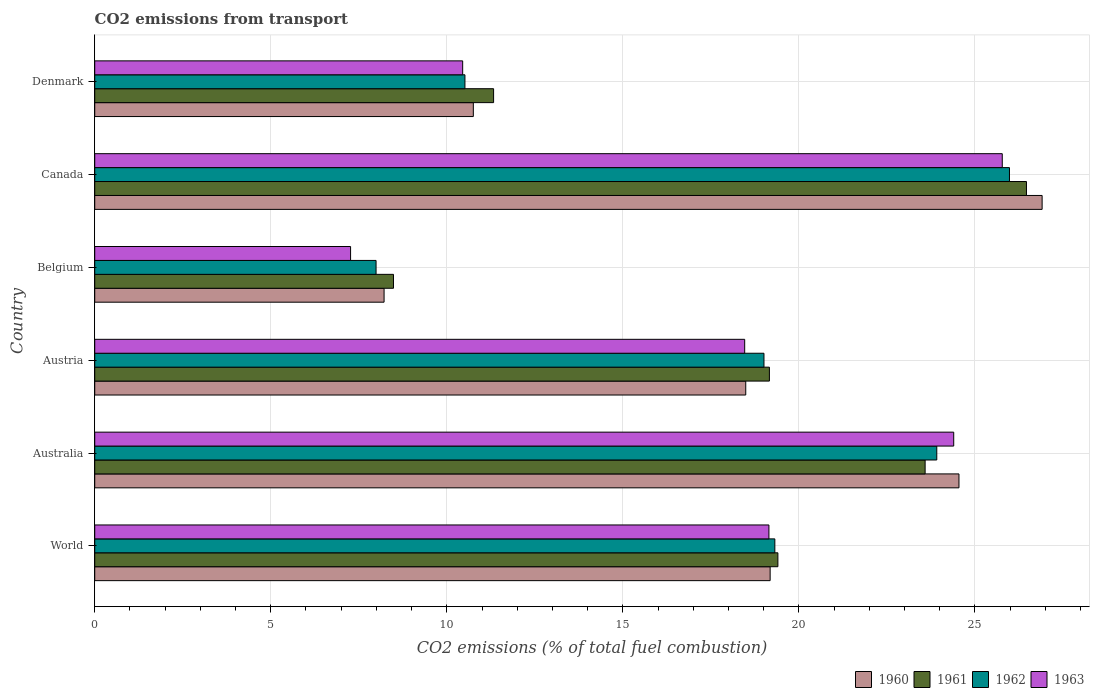How many different coloured bars are there?
Offer a very short reply. 4. How many groups of bars are there?
Make the answer very short. 6. How many bars are there on the 5th tick from the top?
Offer a terse response. 4. How many bars are there on the 3rd tick from the bottom?
Give a very brief answer. 4. In how many cases, is the number of bars for a given country not equal to the number of legend labels?
Give a very brief answer. 0. What is the total CO2 emitted in 1962 in Canada?
Give a very brief answer. 25.98. Across all countries, what is the maximum total CO2 emitted in 1960?
Your answer should be very brief. 26.91. Across all countries, what is the minimum total CO2 emitted in 1960?
Provide a short and direct response. 8.22. In which country was the total CO2 emitted in 1962 maximum?
Provide a short and direct response. Canada. In which country was the total CO2 emitted in 1961 minimum?
Offer a terse response. Belgium. What is the total total CO2 emitted in 1962 in the graph?
Offer a very short reply. 106.73. What is the difference between the total CO2 emitted in 1960 in Austria and that in World?
Your response must be concise. -0.69. What is the difference between the total CO2 emitted in 1963 in Austria and the total CO2 emitted in 1960 in World?
Offer a terse response. -0.72. What is the average total CO2 emitted in 1960 per country?
Provide a short and direct response. 18.02. What is the difference between the total CO2 emitted in 1963 and total CO2 emitted in 1961 in Denmark?
Make the answer very short. -0.88. What is the ratio of the total CO2 emitted in 1960 in Canada to that in Denmark?
Your response must be concise. 2.5. What is the difference between the highest and the second highest total CO2 emitted in 1962?
Your answer should be very brief. 2.06. What is the difference between the highest and the lowest total CO2 emitted in 1960?
Provide a succinct answer. 18.69. In how many countries, is the total CO2 emitted in 1960 greater than the average total CO2 emitted in 1960 taken over all countries?
Offer a very short reply. 4. What does the 2nd bar from the top in Belgium represents?
Make the answer very short. 1962. What is the difference between two consecutive major ticks on the X-axis?
Provide a succinct answer. 5. Are the values on the major ticks of X-axis written in scientific E-notation?
Make the answer very short. No. Does the graph contain any zero values?
Provide a short and direct response. No. Where does the legend appear in the graph?
Provide a succinct answer. Bottom right. How are the legend labels stacked?
Keep it short and to the point. Horizontal. What is the title of the graph?
Your answer should be compact. CO2 emissions from transport. Does "2011" appear as one of the legend labels in the graph?
Make the answer very short. No. What is the label or title of the X-axis?
Give a very brief answer. CO2 emissions (% of total fuel combustion). What is the label or title of the Y-axis?
Your response must be concise. Country. What is the CO2 emissions (% of total fuel combustion) in 1960 in World?
Offer a very short reply. 19.18. What is the CO2 emissions (% of total fuel combustion) in 1961 in World?
Provide a short and direct response. 19.4. What is the CO2 emissions (% of total fuel combustion) of 1962 in World?
Offer a terse response. 19.32. What is the CO2 emissions (% of total fuel combustion) in 1963 in World?
Your response must be concise. 19.15. What is the CO2 emissions (% of total fuel combustion) in 1960 in Australia?
Offer a very short reply. 24.55. What is the CO2 emissions (% of total fuel combustion) in 1961 in Australia?
Give a very brief answer. 23.59. What is the CO2 emissions (% of total fuel combustion) in 1962 in Australia?
Provide a succinct answer. 23.92. What is the CO2 emissions (% of total fuel combustion) in 1963 in Australia?
Ensure brevity in your answer.  24.4. What is the CO2 emissions (% of total fuel combustion) of 1960 in Austria?
Offer a very short reply. 18.49. What is the CO2 emissions (% of total fuel combustion) of 1961 in Austria?
Offer a terse response. 19.16. What is the CO2 emissions (% of total fuel combustion) of 1962 in Austria?
Provide a short and direct response. 19.01. What is the CO2 emissions (% of total fuel combustion) in 1963 in Austria?
Offer a very short reply. 18.46. What is the CO2 emissions (% of total fuel combustion) in 1960 in Belgium?
Offer a terse response. 8.22. What is the CO2 emissions (% of total fuel combustion) in 1961 in Belgium?
Ensure brevity in your answer.  8.49. What is the CO2 emissions (% of total fuel combustion) of 1962 in Belgium?
Offer a very short reply. 7.99. What is the CO2 emissions (% of total fuel combustion) of 1963 in Belgium?
Offer a terse response. 7.27. What is the CO2 emissions (% of total fuel combustion) in 1960 in Canada?
Give a very brief answer. 26.91. What is the CO2 emissions (% of total fuel combustion) in 1961 in Canada?
Offer a terse response. 26.46. What is the CO2 emissions (% of total fuel combustion) in 1962 in Canada?
Keep it short and to the point. 25.98. What is the CO2 emissions (% of total fuel combustion) of 1963 in Canada?
Provide a succinct answer. 25.78. What is the CO2 emissions (% of total fuel combustion) of 1960 in Denmark?
Your answer should be very brief. 10.75. What is the CO2 emissions (% of total fuel combustion) of 1961 in Denmark?
Offer a terse response. 11.33. What is the CO2 emissions (% of total fuel combustion) of 1962 in Denmark?
Offer a very short reply. 10.51. What is the CO2 emissions (% of total fuel combustion) of 1963 in Denmark?
Keep it short and to the point. 10.45. Across all countries, what is the maximum CO2 emissions (% of total fuel combustion) of 1960?
Make the answer very short. 26.91. Across all countries, what is the maximum CO2 emissions (% of total fuel combustion) of 1961?
Offer a terse response. 26.46. Across all countries, what is the maximum CO2 emissions (% of total fuel combustion) in 1962?
Offer a terse response. 25.98. Across all countries, what is the maximum CO2 emissions (% of total fuel combustion) of 1963?
Your response must be concise. 25.78. Across all countries, what is the minimum CO2 emissions (% of total fuel combustion) of 1960?
Ensure brevity in your answer.  8.22. Across all countries, what is the minimum CO2 emissions (% of total fuel combustion) of 1961?
Make the answer very short. 8.49. Across all countries, what is the minimum CO2 emissions (% of total fuel combustion) of 1962?
Keep it short and to the point. 7.99. Across all countries, what is the minimum CO2 emissions (% of total fuel combustion) of 1963?
Offer a very short reply. 7.27. What is the total CO2 emissions (% of total fuel combustion) of 1960 in the graph?
Your answer should be very brief. 108.1. What is the total CO2 emissions (% of total fuel combustion) of 1961 in the graph?
Offer a terse response. 108.43. What is the total CO2 emissions (% of total fuel combustion) of 1962 in the graph?
Ensure brevity in your answer.  106.73. What is the total CO2 emissions (% of total fuel combustion) of 1963 in the graph?
Your answer should be compact. 105.5. What is the difference between the CO2 emissions (% of total fuel combustion) of 1960 in World and that in Australia?
Your answer should be very brief. -5.36. What is the difference between the CO2 emissions (% of total fuel combustion) of 1961 in World and that in Australia?
Provide a short and direct response. -4.18. What is the difference between the CO2 emissions (% of total fuel combustion) of 1962 in World and that in Australia?
Make the answer very short. -4.6. What is the difference between the CO2 emissions (% of total fuel combustion) of 1963 in World and that in Australia?
Offer a very short reply. -5.25. What is the difference between the CO2 emissions (% of total fuel combustion) of 1960 in World and that in Austria?
Keep it short and to the point. 0.69. What is the difference between the CO2 emissions (% of total fuel combustion) of 1961 in World and that in Austria?
Provide a succinct answer. 0.24. What is the difference between the CO2 emissions (% of total fuel combustion) of 1962 in World and that in Austria?
Your answer should be compact. 0.31. What is the difference between the CO2 emissions (% of total fuel combustion) of 1963 in World and that in Austria?
Ensure brevity in your answer.  0.69. What is the difference between the CO2 emissions (% of total fuel combustion) of 1960 in World and that in Belgium?
Your answer should be compact. 10.96. What is the difference between the CO2 emissions (% of total fuel combustion) of 1961 in World and that in Belgium?
Offer a terse response. 10.92. What is the difference between the CO2 emissions (% of total fuel combustion) of 1962 in World and that in Belgium?
Your answer should be very brief. 11.33. What is the difference between the CO2 emissions (% of total fuel combustion) in 1963 in World and that in Belgium?
Offer a terse response. 11.88. What is the difference between the CO2 emissions (% of total fuel combustion) of 1960 in World and that in Canada?
Your response must be concise. -7.72. What is the difference between the CO2 emissions (% of total fuel combustion) in 1961 in World and that in Canada?
Provide a short and direct response. -7.06. What is the difference between the CO2 emissions (% of total fuel combustion) in 1962 in World and that in Canada?
Offer a very short reply. -6.66. What is the difference between the CO2 emissions (% of total fuel combustion) in 1963 in World and that in Canada?
Your answer should be compact. -6.63. What is the difference between the CO2 emissions (% of total fuel combustion) in 1960 in World and that in Denmark?
Your response must be concise. 8.43. What is the difference between the CO2 emissions (% of total fuel combustion) in 1961 in World and that in Denmark?
Ensure brevity in your answer.  8.07. What is the difference between the CO2 emissions (% of total fuel combustion) in 1962 in World and that in Denmark?
Your response must be concise. 8.8. What is the difference between the CO2 emissions (% of total fuel combustion) of 1963 in World and that in Denmark?
Offer a terse response. 8.7. What is the difference between the CO2 emissions (% of total fuel combustion) in 1960 in Australia and that in Austria?
Provide a short and direct response. 6.06. What is the difference between the CO2 emissions (% of total fuel combustion) of 1961 in Australia and that in Austria?
Offer a very short reply. 4.42. What is the difference between the CO2 emissions (% of total fuel combustion) of 1962 in Australia and that in Austria?
Your answer should be very brief. 4.91. What is the difference between the CO2 emissions (% of total fuel combustion) in 1963 in Australia and that in Austria?
Ensure brevity in your answer.  5.94. What is the difference between the CO2 emissions (% of total fuel combustion) of 1960 in Australia and that in Belgium?
Your answer should be very brief. 16.33. What is the difference between the CO2 emissions (% of total fuel combustion) in 1961 in Australia and that in Belgium?
Your response must be concise. 15.1. What is the difference between the CO2 emissions (% of total fuel combustion) in 1962 in Australia and that in Belgium?
Ensure brevity in your answer.  15.93. What is the difference between the CO2 emissions (% of total fuel combustion) in 1963 in Australia and that in Belgium?
Ensure brevity in your answer.  17.13. What is the difference between the CO2 emissions (% of total fuel combustion) of 1960 in Australia and that in Canada?
Provide a succinct answer. -2.36. What is the difference between the CO2 emissions (% of total fuel combustion) in 1961 in Australia and that in Canada?
Your answer should be compact. -2.88. What is the difference between the CO2 emissions (% of total fuel combustion) of 1962 in Australia and that in Canada?
Provide a succinct answer. -2.06. What is the difference between the CO2 emissions (% of total fuel combustion) of 1963 in Australia and that in Canada?
Make the answer very short. -1.38. What is the difference between the CO2 emissions (% of total fuel combustion) in 1960 in Australia and that in Denmark?
Provide a succinct answer. 13.79. What is the difference between the CO2 emissions (% of total fuel combustion) of 1961 in Australia and that in Denmark?
Your response must be concise. 12.26. What is the difference between the CO2 emissions (% of total fuel combustion) of 1962 in Australia and that in Denmark?
Your answer should be very brief. 13.4. What is the difference between the CO2 emissions (% of total fuel combustion) in 1963 in Australia and that in Denmark?
Provide a succinct answer. 13.95. What is the difference between the CO2 emissions (% of total fuel combustion) in 1960 in Austria and that in Belgium?
Provide a short and direct response. 10.27. What is the difference between the CO2 emissions (% of total fuel combustion) of 1961 in Austria and that in Belgium?
Keep it short and to the point. 10.68. What is the difference between the CO2 emissions (% of total fuel combustion) in 1962 in Austria and that in Belgium?
Your answer should be compact. 11.02. What is the difference between the CO2 emissions (% of total fuel combustion) of 1963 in Austria and that in Belgium?
Provide a short and direct response. 11.19. What is the difference between the CO2 emissions (% of total fuel combustion) of 1960 in Austria and that in Canada?
Your answer should be compact. -8.42. What is the difference between the CO2 emissions (% of total fuel combustion) in 1961 in Austria and that in Canada?
Ensure brevity in your answer.  -7.3. What is the difference between the CO2 emissions (% of total fuel combustion) of 1962 in Austria and that in Canada?
Make the answer very short. -6.97. What is the difference between the CO2 emissions (% of total fuel combustion) of 1963 in Austria and that in Canada?
Keep it short and to the point. -7.32. What is the difference between the CO2 emissions (% of total fuel combustion) in 1960 in Austria and that in Denmark?
Give a very brief answer. 7.74. What is the difference between the CO2 emissions (% of total fuel combustion) of 1961 in Austria and that in Denmark?
Ensure brevity in your answer.  7.83. What is the difference between the CO2 emissions (% of total fuel combustion) of 1962 in Austria and that in Denmark?
Offer a very short reply. 8.49. What is the difference between the CO2 emissions (% of total fuel combustion) of 1963 in Austria and that in Denmark?
Your response must be concise. 8.01. What is the difference between the CO2 emissions (% of total fuel combustion) of 1960 in Belgium and that in Canada?
Ensure brevity in your answer.  -18.69. What is the difference between the CO2 emissions (% of total fuel combustion) in 1961 in Belgium and that in Canada?
Keep it short and to the point. -17.98. What is the difference between the CO2 emissions (% of total fuel combustion) of 1962 in Belgium and that in Canada?
Provide a succinct answer. -17.99. What is the difference between the CO2 emissions (% of total fuel combustion) in 1963 in Belgium and that in Canada?
Your response must be concise. -18.51. What is the difference between the CO2 emissions (% of total fuel combustion) in 1960 in Belgium and that in Denmark?
Give a very brief answer. -2.53. What is the difference between the CO2 emissions (% of total fuel combustion) in 1961 in Belgium and that in Denmark?
Offer a very short reply. -2.84. What is the difference between the CO2 emissions (% of total fuel combustion) of 1962 in Belgium and that in Denmark?
Your answer should be very brief. -2.52. What is the difference between the CO2 emissions (% of total fuel combustion) in 1963 in Belgium and that in Denmark?
Offer a terse response. -3.18. What is the difference between the CO2 emissions (% of total fuel combustion) in 1960 in Canada and that in Denmark?
Give a very brief answer. 16.16. What is the difference between the CO2 emissions (% of total fuel combustion) in 1961 in Canada and that in Denmark?
Give a very brief answer. 15.13. What is the difference between the CO2 emissions (% of total fuel combustion) of 1962 in Canada and that in Denmark?
Provide a short and direct response. 15.47. What is the difference between the CO2 emissions (% of total fuel combustion) of 1963 in Canada and that in Denmark?
Offer a terse response. 15.33. What is the difference between the CO2 emissions (% of total fuel combustion) in 1960 in World and the CO2 emissions (% of total fuel combustion) in 1961 in Australia?
Give a very brief answer. -4.4. What is the difference between the CO2 emissions (% of total fuel combustion) of 1960 in World and the CO2 emissions (% of total fuel combustion) of 1962 in Australia?
Provide a succinct answer. -4.73. What is the difference between the CO2 emissions (% of total fuel combustion) of 1960 in World and the CO2 emissions (% of total fuel combustion) of 1963 in Australia?
Provide a short and direct response. -5.21. What is the difference between the CO2 emissions (% of total fuel combustion) of 1961 in World and the CO2 emissions (% of total fuel combustion) of 1962 in Australia?
Provide a succinct answer. -4.51. What is the difference between the CO2 emissions (% of total fuel combustion) in 1961 in World and the CO2 emissions (% of total fuel combustion) in 1963 in Australia?
Make the answer very short. -4.99. What is the difference between the CO2 emissions (% of total fuel combustion) in 1962 in World and the CO2 emissions (% of total fuel combustion) in 1963 in Australia?
Make the answer very short. -5.08. What is the difference between the CO2 emissions (% of total fuel combustion) in 1960 in World and the CO2 emissions (% of total fuel combustion) in 1961 in Austria?
Make the answer very short. 0.02. What is the difference between the CO2 emissions (% of total fuel combustion) of 1960 in World and the CO2 emissions (% of total fuel combustion) of 1962 in Austria?
Your answer should be very brief. 0.18. What is the difference between the CO2 emissions (% of total fuel combustion) in 1960 in World and the CO2 emissions (% of total fuel combustion) in 1963 in Austria?
Provide a short and direct response. 0.72. What is the difference between the CO2 emissions (% of total fuel combustion) in 1961 in World and the CO2 emissions (% of total fuel combustion) in 1962 in Austria?
Your answer should be very brief. 0.4. What is the difference between the CO2 emissions (% of total fuel combustion) of 1961 in World and the CO2 emissions (% of total fuel combustion) of 1963 in Austria?
Offer a terse response. 0.94. What is the difference between the CO2 emissions (% of total fuel combustion) of 1962 in World and the CO2 emissions (% of total fuel combustion) of 1963 in Austria?
Ensure brevity in your answer.  0.86. What is the difference between the CO2 emissions (% of total fuel combustion) of 1960 in World and the CO2 emissions (% of total fuel combustion) of 1961 in Belgium?
Offer a terse response. 10.7. What is the difference between the CO2 emissions (% of total fuel combustion) of 1960 in World and the CO2 emissions (% of total fuel combustion) of 1962 in Belgium?
Make the answer very short. 11.19. What is the difference between the CO2 emissions (% of total fuel combustion) of 1960 in World and the CO2 emissions (% of total fuel combustion) of 1963 in Belgium?
Ensure brevity in your answer.  11.92. What is the difference between the CO2 emissions (% of total fuel combustion) of 1961 in World and the CO2 emissions (% of total fuel combustion) of 1962 in Belgium?
Ensure brevity in your answer.  11.41. What is the difference between the CO2 emissions (% of total fuel combustion) in 1961 in World and the CO2 emissions (% of total fuel combustion) in 1963 in Belgium?
Your answer should be compact. 12.14. What is the difference between the CO2 emissions (% of total fuel combustion) of 1962 in World and the CO2 emissions (% of total fuel combustion) of 1963 in Belgium?
Make the answer very short. 12.05. What is the difference between the CO2 emissions (% of total fuel combustion) of 1960 in World and the CO2 emissions (% of total fuel combustion) of 1961 in Canada?
Your response must be concise. -7.28. What is the difference between the CO2 emissions (% of total fuel combustion) in 1960 in World and the CO2 emissions (% of total fuel combustion) in 1962 in Canada?
Keep it short and to the point. -6.8. What is the difference between the CO2 emissions (% of total fuel combustion) in 1960 in World and the CO2 emissions (% of total fuel combustion) in 1963 in Canada?
Provide a short and direct response. -6.59. What is the difference between the CO2 emissions (% of total fuel combustion) of 1961 in World and the CO2 emissions (% of total fuel combustion) of 1962 in Canada?
Offer a terse response. -6.58. What is the difference between the CO2 emissions (% of total fuel combustion) in 1961 in World and the CO2 emissions (% of total fuel combustion) in 1963 in Canada?
Provide a succinct answer. -6.37. What is the difference between the CO2 emissions (% of total fuel combustion) in 1962 in World and the CO2 emissions (% of total fuel combustion) in 1963 in Canada?
Ensure brevity in your answer.  -6.46. What is the difference between the CO2 emissions (% of total fuel combustion) of 1960 in World and the CO2 emissions (% of total fuel combustion) of 1961 in Denmark?
Your response must be concise. 7.85. What is the difference between the CO2 emissions (% of total fuel combustion) of 1960 in World and the CO2 emissions (% of total fuel combustion) of 1962 in Denmark?
Offer a terse response. 8.67. What is the difference between the CO2 emissions (% of total fuel combustion) in 1960 in World and the CO2 emissions (% of total fuel combustion) in 1963 in Denmark?
Your answer should be compact. 8.73. What is the difference between the CO2 emissions (% of total fuel combustion) in 1961 in World and the CO2 emissions (% of total fuel combustion) in 1962 in Denmark?
Your answer should be compact. 8.89. What is the difference between the CO2 emissions (% of total fuel combustion) of 1961 in World and the CO2 emissions (% of total fuel combustion) of 1963 in Denmark?
Your answer should be compact. 8.95. What is the difference between the CO2 emissions (% of total fuel combustion) of 1962 in World and the CO2 emissions (% of total fuel combustion) of 1963 in Denmark?
Your answer should be very brief. 8.87. What is the difference between the CO2 emissions (% of total fuel combustion) in 1960 in Australia and the CO2 emissions (% of total fuel combustion) in 1961 in Austria?
Make the answer very short. 5.38. What is the difference between the CO2 emissions (% of total fuel combustion) of 1960 in Australia and the CO2 emissions (% of total fuel combustion) of 1962 in Austria?
Provide a succinct answer. 5.54. What is the difference between the CO2 emissions (% of total fuel combustion) of 1960 in Australia and the CO2 emissions (% of total fuel combustion) of 1963 in Austria?
Your answer should be compact. 6.09. What is the difference between the CO2 emissions (% of total fuel combustion) of 1961 in Australia and the CO2 emissions (% of total fuel combustion) of 1962 in Austria?
Give a very brief answer. 4.58. What is the difference between the CO2 emissions (% of total fuel combustion) in 1961 in Australia and the CO2 emissions (% of total fuel combustion) in 1963 in Austria?
Your answer should be very brief. 5.13. What is the difference between the CO2 emissions (% of total fuel combustion) in 1962 in Australia and the CO2 emissions (% of total fuel combustion) in 1963 in Austria?
Ensure brevity in your answer.  5.46. What is the difference between the CO2 emissions (% of total fuel combustion) of 1960 in Australia and the CO2 emissions (% of total fuel combustion) of 1961 in Belgium?
Make the answer very short. 16.06. What is the difference between the CO2 emissions (% of total fuel combustion) in 1960 in Australia and the CO2 emissions (% of total fuel combustion) in 1962 in Belgium?
Provide a short and direct response. 16.56. What is the difference between the CO2 emissions (% of total fuel combustion) of 1960 in Australia and the CO2 emissions (% of total fuel combustion) of 1963 in Belgium?
Offer a terse response. 17.28. What is the difference between the CO2 emissions (% of total fuel combustion) of 1961 in Australia and the CO2 emissions (% of total fuel combustion) of 1962 in Belgium?
Your response must be concise. 15.59. What is the difference between the CO2 emissions (% of total fuel combustion) in 1961 in Australia and the CO2 emissions (% of total fuel combustion) in 1963 in Belgium?
Ensure brevity in your answer.  16.32. What is the difference between the CO2 emissions (% of total fuel combustion) in 1962 in Australia and the CO2 emissions (% of total fuel combustion) in 1963 in Belgium?
Give a very brief answer. 16.65. What is the difference between the CO2 emissions (% of total fuel combustion) in 1960 in Australia and the CO2 emissions (% of total fuel combustion) in 1961 in Canada?
Offer a terse response. -1.92. What is the difference between the CO2 emissions (% of total fuel combustion) in 1960 in Australia and the CO2 emissions (% of total fuel combustion) in 1962 in Canada?
Give a very brief answer. -1.43. What is the difference between the CO2 emissions (% of total fuel combustion) in 1960 in Australia and the CO2 emissions (% of total fuel combustion) in 1963 in Canada?
Make the answer very short. -1.23. What is the difference between the CO2 emissions (% of total fuel combustion) of 1961 in Australia and the CO2 emissions (% of total fuel combustion) of 1962 in Canada?
Ensure brevity in your answer.  -2.4. What is the difference between the CO2 emissions (% of total fuel combustion) of 1961 in Australia and the CO2 emissions (% of total fuel combustion) of 1963 in Canada?
Ensure brevity in your answer.  -2.19. What is the difference between the CO2 emissions (% of total fuel combustion) of 1962 in Australia and the CO2 emissions (% of total fuel combustion) of 1963 in Canada?
Make the answer very short. -1.86. What is the difference between the CO2 emissions (% of total fuel combustion) of 1960 in Australia and the CO2 emissions (% of total fuel combustion) of 1961 in Denmark?
Your answer should be compact. 13.22. What is the difference between the CO2 emissions (% of total fuel combustion) of 1960 in Australia and the CO2 emissions (% of total fuel combustion) of 1962 in Denmark?
Offer a terse response. 14.03. What is the difference between the CO2 emissions (% of total fuel combustion) of 1960 in Australia and the CO2 emissions (% of total fuel combustion) of 1963 in Denmark?
Your response must be concise. 14.1. What is the difference between the CO2 emissions (% of total fuel combustion) of 1961 in Australia and the CO2 emissions (% of total fuel combustion) of 1962 in Denmark?
Ensure brevity in your answer.  13.07. What is the difference between the CO2 emissions (% of total fuel combustion) in 1961 in Australia and the CO2 emissions (% of total fuel combustion) in 1963 in Denmark?
Provide a short and direct response. 13.13. What is the difference between the CO2 emissions (% of total fuel combustion) of 1962 in Australia and the CO2 emissions (% of total fuel combustion) of 1963 in Denmark?
Keep it short and to the point. 13.47. What is the difference between the CO2 emissions (% of total fuel combustion) of 1960 in Austria and the CO2 emissions (% of total fuel combustion) of 1961 in Belgium?
Your response must be concise. 10. What is the difference between the CO2 emissions (% of total fuel combustion) of 1960 in Austria and the CO2 emissions (% of total fuel combustion) of 1962 in Belgium?
Offer a very short reply. 10.5. What is the difference between the CO2 emissions (% of total fuel combustion) of 1960 in Austria and the CO2 emissions (% of total fuel combustion) of 1963 in Belgium?
Your response must be concise. 11.22. What is the difference between the CO2 emissions (% of total fuel combustion) of 1961 in Austria and the CO2 emissions (% of total fuel combustion) of 1962 in Belgium?
Provide a succinct answer. 11.17. What is the difference between the CO2 emissions (% of total fuel combustion) in 1961 in Austria and the CO2 emissions (% of total fuel combustion) in 1963 in Belgium?
Give a very brief answer. 11.9. What is the difference between the CO2 emissions (% of total fuel combustion) in 1962 in Austria and the CO2 emissions (% of total fuel combustion) in 1963 in Belgium?
Your answer should be compact. 11.74. What is the difference between the CO2 emissions (% of total fuel combustion) in 1960 in Austria and the CO2 emissions (% of total fuel combustion) in 1961 in Canada?
Keep it short and to the point. -7.97. What is the difference between the CO2 emissions (% of total fuel combustion) of 1960 in Austria and the CO2 emissions (% of total fuel combustion) of 1962 in Canada?
Your answer should be very brief. -7.49. What is the difference between the CO2 emissions (% of total fuel combustion) of 1960 in Austria and the CO2 emissions (% of total fuel combustion) of 1963 in Canada?
Keep it short and to the point. -7.29. What is the difference between the CO2 emissions (% of total fuel combustion) of 1961 in Austria and the CO2 emissions (% of total fuel combustion) of 1962 in Canada?
Keep it short and to the point. -6.82. What is the difference between the CO2 emissions (% of total fuel combustion) of 1961 in Austria and the CO2 emissions (% of total fuel combustion) of 1963 in Canada?
Your answer should be very brief. -6.61. What is the difference between the CO2 emissions (% of total fuel combustion) in 1962 in Austria and the CO2 emissions (% of total fuel combustion) in 1963 in Canada?
Provide a short and direct response. -6.77. What is the difference between the CO2 emissions (% of total fuel combustion) in 1960 in Austria and the CO2 emissions (% of total fuel combustion) in 1961 in Denmark?
Offer a very short reply. 7.16. What is the difference between the CO2 emissions (% of total fuel combustion) of 1960 in Austria and the CO2 emissions (% of total fuel combustion) of 1962 in Denmark?
Your answer should be very brief. 7.98. What is the difference between the CO2 emissions (% of total fuel combustion) in 1960 in Austria and the CO2 emissions (% of total fuel combustion) in 1963 in Denmark?
Ensure brevity in your answer.  8.04. What is the difference between the CO2 emissions (% of total fuel combustion) of 1961 in Austria and the CO2 emissions (% of total fuel combustion) of 1962 in Denmark?
Your answer should be very brief. 8.65. What is the difference between the CO2 emissions (% of total fuel combustion) of 1961 in Austria and the CO2 emissions (% of total fuel combustion) of 1963 in Denmark?
Make the answer very short. 8.71. What is the difference between the CO2 emissions (% of total fuel combustion) in 1962 in Austria and the CO2 emissions (% of total fuel combustion) in 1963 in Denmark?
Provide a succinct answer. 8.56. What is the difference between the CO2 emissions (% of total fuel combustion) in 1960 in Belgium and the CO2 emissions (% of total fuel combustion) in 1961 in Canada?
Offer a terse response. -18.25. What is the difference between the CO2 emissions (% of total fuel combustion) in 1960 in Belgium and the CO2 emissions (% of total fuel combustion) in 1962 in Canada?
Your response must be concise. -17.76. What is the difference between the CO2 emissions (% of total fuel combustion) of 1960 in Belgium and the CO2 emissions (% of total fuel combustion) of 1963 in Canada?
Your answer should be compact. -17.56. What is the difference between the CO2 emissions (% of total fuel combustion) in 1961 in Belgium and the CO2 emissions (% of total fuel combustion) in 1962 in Canada?
Your response must be concise. -17.5. What is the difference between the CO2 emissions (% of total fuel combustion) of 1961 in Belgium and the CO2 emissions (% of total fuel combustion) of 1963 in Canada?
Provide a short and direct response. -17.29. What is the difference between the CO2 emissions (% of total fuel combustion) of 1962 in Belgium and the CO2 emissions (% of total fuel combustion) of 1963 in Canada?
Offer a terse response. -17.79. What is the difference between the CO2 emissions (% of total fuel combustion) in 1960 in Belgium and the CO2 emissions (% of total fuel combustion) in 1961 in Denmark?
Ensure brevity in your answer.  -3.11. What is the difference between the CO2 emissions (% of total fuel combustion) in 1960 in Belgium and the CO2 emissions (% of total fuel combustion) in 1962 in Denmark?
Offer a terse response. -2.3. What is the difference between the CO2 emissions (% of total fuel combustion) in 1960 in Belgium and the CO2 emissions (% of total fuel combustion) in 1963 in Denmark?
Make the answer very short. -2.23. What is the difference between the CO2 emissions (% of total fuel combustion) in 1961 in Belgium and the CO2 emissions (% of total fuel combustion) in 1962 in Denmark?
Your answer should be compact. -2.03. What is the difference between the CO2 emissions (% of total fuel combustion) of 1961 in Belgium and the CO2 emissions (% of total fuel combustion) of 1963 in Denmark?
Keep it short and to the point. -1.96. What is the difference between the CO2 emissions (% of total fuel combustion) of 1962 in Belgium and the CO2 emissions (% of total fuel combustion) of 1963 in Denmark?
Your answer should be very brief. -2.46. What is the difference between the CO2 emissions (% of total fuel combustion) of 1960 in Canada and the CO2 emissions (% of total fuel combustion) of 1961 in Denmark?
Your answer should be very brief. 15.58. What is the difference between the CO2 emissions (% of total fuel combustion) of 1960 in Canada and the CO2 emissions (% of total fuel combustion) of 1962 in Denmark?
Give a very brief answer. 16.39. What is the difference between the CO2 emissions (% of total fuel combustion) of 1960 in Canada and the CO2 emissions (% of total fuel combustion) of 1963 in Denmark?
Keep it short and to the point. 16.46. What is the difference between the CO2 emissions (% of total fuel combustion) of 1961 in Canada and the CO2 emissions (% of total fuel combustion) of 1962 in Denmark?
Your response must be concise. 15.95. What is the difference between the CO2 emissions (% of total fuel combustion) in 1961 in Canada and the CO2 emissions (% of total fuel combustion) in 1963 in Denmark?
Keep it short and to the point. 16.01. What is the difference between the CO2 emissions (% of total fuel combustion) in 1962 in Canada and the CO2 emissions (% of total fuel combustion) in 1963 in Denmark?
Provide a short and direct response. 15.53. What is the average CO2 emissions (% of total fuel combustion) of 1960 per country?
Your answer should be very brief. 18.02. What is the average CO2 emissions (% of total fuel combustion) in 1961 per country?
Provide a succinct answer. 18.07. What is the average CO2 emissions (% of total fuel combustion) in 1962 per country?
Your answer should be compact. 17.79. What is the average CO2 emissions (% of total fuel combustion) in 1963 per country?
Your response must be concise. 17.58. What is the difference between the CO2 emissions (% of total fuel combustion) in 1960 and CO2 emissions (% of total fuel combustion) in 1961 in World?
Your answer should be compact. -0.22. What is the difference between the CO2 emissions (% of total fuel combustion) of 1960 and CO2 emissions (% of total fuel combustion) of 1962 in World?
Offer a terse response. -0.13. What is the difference between the CO2 emissions (% of total fuel combustion) in 1960 and CO2 emissions (% of total fuel combustion) in 1963 in World?
Give a very brief answer. 0.03. What is the difference between the CO2 emissions (% of total fuel combustion) of 1961 and CO2 emissions (% of total fuel combustion) of 1962 in World?
Make the answer very short. 0.09. What is the difference between the CO2 emissions (% of total fuel combustion) in 1961 and CO2 emissions (% of total fuel combustion) in 1963 in World?
Make the answer very short. 0.25. What is the difference between the CO2 emissions (% of total fuel combustion) of 1962 and CO2 emissions (% of total fuel combustion) of 1963 in World?
Make the answer very short. 0.17. What is the difference between the CO2 emissions (% of total fuel combustion) in 1960 and CO2 emissions (% of total fuel combustion) in 1961 in Australia?
Offer a terse response. 0.96. What is the difference between the CO2 emissions (% of total fuel combustion) of 1960 and CO2 emissions (% of total fuel combustion) of 1962 in Australia?
Your response must be concise. 0.63. What is the difference between the CO2 emissions (% of total fuel combustion) in 1960 and CO2 emissions (% of total fuel combustion) in 1963 in Australia?
Give a very brief answer. 0.15. What is the difference between the CO2 emissions (% of total fuel combustion) in 1961 and CO2 emissions (% of total fuel combustion) in 1962 in Australia?
Offer a very short reply. -0.33. What is the difference between the CO2 emissions (% of total fuel combustion) of 1961 and CO2 emissions (% of total fuel combustion) of 1963 in Australia?
Provide a succinct answer. -0.81. What is the difference between the CO2 emissions (% of total fuel combustion) of 1962 and CO2 emissions (% of total fuel combustion) of 1963 in Australia?
Keep it short and to the point. -0.48. What is the difference between the CO2 emissions (% of total fuel combustion) in 1960 and CO2 emissions (% of total fuel combustion) in 1961 in Austria?
Give a very brief answer. -0.67. What is the difference between the CO2 emissions (% of total fuel combustion) in 1960 and CO2 emissions (% of total fuel combustion) in 1962 in Austria?
Your answer should be compact. -0.52. What is the difference between the CO2 emissions (% of total fuel combustion) of 1960 and CO2 emissions (% of total fuel combustion) of 1963 in Austria?
Your response must be concise. 0.03. What is the difference between the CO2 emissions (% of total fuel combustion) in 1961 and CO2 emissions (% of total fuel combustion) in 1962 in Austria?
Offer a terse response. 0.15. What is the difference between the CO2 emissions (% of total fuel combustion) of 1961 and CO2 emissions (% of total fuel combustion) of 1963 in Austria?
Offer a very short reply. 0.7. What is the difference between the CO2 emissions (% of total fuel combustion) of 1962 and CO2 emissions (% of total fuel combustion) of 1963 in Austria?
Your answer should be very brief. 0.55. What is the difference between the CO2 emissions (% of total fuel combustion) in 1960 and CO2 emissions (% of total fuel combustion) in 1961 in Belgium?
Ensure brevity in your answer.  -0.27. What is the difference between the CO2 emissions (% of total fuel combustion) of 1960 and CO2 emissions (% of total fuel combustion) of 1962 in Belgium?
Offer a terse response. 0.23. What is the difference between the CO2 emissions (% of total fuel combustion) of 1960 and CO2 emissions (% of total fuel combustion) of 1963 in Belgium?
Keep it short and to the point. 0.95. What is the difference between the CO2 emissions (% of total fuel combustion) in 1961 and CO2 emissions (% of total fuel combustion) in 1962 in Belgium?
Your answer should be very brief. 0.49. What is the difference between the CO2 emissions (% of total fuel combustion) in 1961 and CO2 emissions (% of total fuel combustion) in 1963 in Belgium?
Provide a succinct answer. 1.22. What is the difference between the CO2 emissions (% of total fuel combustion) of 1962 and CO2 emissions (% of total fuel combustion) of 1963 in Belgium?
Offer a terse response. 0.72. What is the difference between the CO2 emissions (% of total fuel combustion) in 1960 and CO2 emissions (% of total fuel combustion) in 1961 in Canada?
Give a very brief answer. 0.44. What is the difference between the CO2 emissions (% of total fuel combustion) of 1960 and CO2 emissions (% of total fuel combustion) of 1962 in Canada?
Provide a short and direct response. 0.93. What is the difference between the CO2 emissions (% of total fuel combustion) in 1960 and CO2 emissions (% of total fuel combustion) in 1963 in Canada?
Your answer should be compact. 1.13. What is the difference between the CO2 emissions (% of total fuel combustion) in 1961 and CO2 emissions (% of total fuel combustion) in 1962 in Canada?
Your answer should be very brief. 0.48. What is the difference between the CO2 emissions (% of total fuel combustion) of 1961 and CO2 emissions (% of total fuel combustion) of 1963 in Canada?
Make the answer very short. 0.69. What is the difference between the CO2 emissions (% of total fuel combustion) in 1962 and CO2 emissions (% of total fuel combustion) in 1963 in Canada?
Your response must be concise. 0.2. What is the difference between the CO2 emissions (% of total fuel combustion) in 1960 and CO2 emissions (% of total fuel combustion) in 1961 in Denmark?
Give a very brief answer. -0.58. What is the difference between the CO2 emissions (% of total fuel combustion) of 1960 and CO2 emissions (% of total fuel combustion) of 1962 in Denmark?
Make the answer very short. 0.24. What is the difference between the CO2 emissions (% of total fuel combustion) of 1960 and CO2 emissions (% of total fuel combustion) of 1963 in Denmark?
Keep it short and to the point. 0.3. What is the difference between the CO2 emissions (% of total fuel combustion) of 1961 and CO2 emissions (% of total fuel combustion) of 1962 in Denmark?
Make the answer very short. 0.81. What is the difference between the CO2 emissions (% of total fuel combustion) in 1961 and CO2 emissions (% of total fuel combustion) in 1963 in Denmark?
Keep it short and to the point. 0.88. What is the difference between the CO2 emissions (% of total fuel combustion) in 1962 and CO2 emissions (% of total fuel combustion) in 1963 in Denmark?
Your response must be concise. 0.06. What is the ratio of the CO2 emissions (% of total fuel combustion) in 1960 in World to that in Australia?
Your answer should be compact. 0.78. What is the ratio of the CO2 emissions (% of total fuel combustion) of 1961 in World to that in Australia?
Your answer should be compact. 0.82. What is the ratio of the CO2 emissions (% of total fuel combustion) of 1962 in World to that in Australia?
Offer a terse response. 0.81. What is the ratio of the CO2 emissions (% of total fuel combustion) in 1963 in World to that in Australia?
Your answer should be very brief. 0.78. What is the ratio of the CO2 emissions (% of total fuel combustion) in 1960 in World to that in Austria?
Ensure brevity in your answer.  1.04. What is the ratio of the CO2 emissions (% of total fuel combustion) in 1961 in World to that in Austria?
Ensure brevity in your answer.  1.01. What is the ratio of the CO2 emissions (% of total fuel combustion) of 1962 in World to that in Austria?
Ensure brevity in your answer.  1.02. What is the ratio of the CO2 emissions (% of total fuel combustion) in 1963 in World to that in Austria?
Your response must be concise. 1.04. What is the ratio of the CO2 emissions (% of total fuel combustion) in 1960 in World to that in Belgium?
Your answer should be compact. 2.33. What is the ratio of the CO2 emissions (% of total fuel combustion) in 1961 in World to that in Belgium?
Make the answer very short. 2.29. What is the ratio of the CO2 emissions (% of total fuel combustion) in 1962 in World to that in Belgium?
Your response must be concise. 2.42. What is the ratio of the CO2 emissions (% of total fuel combustion) of 1963 in World to that in Belgium?
Provide a succinct answer. 2.64. What is the ratio of the CO2 emissions (% of total fuel combustion) in 1960 in World to that in Canada?
Offer a very short reply. 0.71. What is the ratio of the CO2 emissions (% of total fuel combustion) of 1961 in World to that in Canada?
Provide a short and direct response. 0.73. What is the ratio of the CO2 emissions (% of total fuel combustion) of 1962 in World to that in Canada?
Your answer should be compact. 0.74. What is the ratio of the CO2 emissions (% of total fuel combustion) of 1963 in World to that in Canada?
Your answer should be compact. 0.74. What is the ratio of the CO2 emissions (% of total fuel combustion) of 1960 in World to that in Denmark?
Give a very brief answer. 1.78. What is the ratio of the CO2 emissions (% of total fuel combustion) in 1961 in World to that in Denmark?
Provide a succinct answer. 1.71. What is the ratio of the CO2 emissions (% of total fuel combustion) in 1962 in World to that in Denmark?
Make the answer very short. 1.84. What is the ratio of the CO2 emissions (% of total fuel combustion) in 1963 in World to that in Denmark?
Offer a very short reply. 1.83. What is the ratio of the CO2 emissions (% of total fuel combustion) in 1960 in Australia to that in Austria?
Offer a very short reply. 1.33. What is the ratio of the CO2 emissions (% of total fuel combustion) in 1961 in Australia to that in Austria?
Offer a very short reply. 1.23. What is the ratio of the CO2 emissions (% of total fuel combustion) in 1962 in Australia to that in Austria?
Your answer should be very brief. 1.26. What is the ratio of the CO2 emissions (% of total fuel combustion) in 1963 in Australia to that in Austria?
Ensure brevity in your answer.  1.32. What is the ratio of the CO2 emissions (% of total fuel combustion) of 1960 in Australia to that in Belgium?
Keep it short and to the point. 2.99. What is the ratio of the CO2 emissions (% of total fuel combustion) in 1961 in Australia to that in Belgium?
Ensure brevity in your answer.  2.78. What is the ratio of the CO2 emissions (% of total fuel combustion) of 1962 in Australia to that in Belgium?
Offer a very short reply. 2.99. What is the ratio of the CO2 emissions (% of total fuel combustion) in 1963 in Australia to that in Belgium?
Your answer should be compact. 3.36. What is the ratio of the CO2 emissions (% of total fuel combustion) of 1960 in Australia to that in Canada?
Provide a succinct answer. 0.91. What is the ratio of the CO2 emissions (% of total fuel combustion) of 1961 in Australia to that in Canada?
Provide a succinct answer. 0.89. What is the ratio of the CO2 emissions (% of total fuel combustion) of 1962 in Australia to that in Canada?
Offer a terse response. 0.92. What is the ratio of the CO2 emissions (% of total fuel combustion) in 1963 in Australia to that in Canada?
Give a very brief answer. 0.95. What is the ratio of the CO2 emissions (% of total fuel combustion) of 1960 in Australia to that in Denmark?
Your response must be concise. 2.28. What is the ratio of the CO2 emissions (% of total fuel combustion) in 1961 in Australia to that in Denmark?
Your answer should be compact. 2.08. What is the ratio of the CO2 emissions (% of total fuel combustion) of 1962 in Australia to that in Denmark?
Keep it short and to the point. 2.27. What is the ratio of the CO2 emissions (% of total fuel combustion) in 1963 in Australia to that in Denmark?
Your answer should be compact. 2.33. What is the ratio of the CO2 emissions (% of total fuel combustion) of 1960 in Austria to that in Belgium?
Your answer should be compact. 2.25. What is the ratio of the CO2 emissions (% of total fuel combustion) in 1961 in Austria to that in Belgium?
Your response must be concise. 2.26. What is the ratio of the CO2 emissions (% of total fuel combustion) in 1962 in Austria to that in Belgium?
Provide a succinct answer. 2.38. What is the ratio of the CO2 emissions (% of total fuel combustion) of 1963 in Austria to that in Belgium?
Your answer should be compact. 2.54. What is the ratio of the CO2 emissions (% of total fuel combustion) in 1960 in Austria to that in Canada?
Your answer should be compact. 0.69. What is the ratio of the CO2 emissions (% of total fuel combustion) in 1961 in Austria to that in Canada?
Provide a succinct answer. 0.72. What is the ratio of the CO2 emissions (% of total fuel combustion) in 1962 in Austria to that in Canada?
Make the answer very short. 0.73. What is the ratio of the CO2 emissions (% of total fuel combustion) of 1963 in Austria to that in Canada?
Your answer should be compact. 0.72. What is the ratio of the CO2 emissions (% of total fuel combustion) in 1960 in Austria to that in Denmark?
Keep it short and to the point. 1.72. What is the ratio of the CO2 emissions (% of total fuel combustion) in 1961 in Austria to that in Denmark?
Offer a very short reply. 1.69. What is the ratio of the CO2 emissions (% of total fuel combustion) in 1962 in Austria to that in Denmark?
Ensure brevity in your answer.  1.81. What is the ratio of the CO2 emissions (% of total fuel combustion) of 1963 in Austria to that in Denmark?
Your response must be concise. 1.77. What is the ratio of the CO2 emissions (% of total fuel combustion) in 1960 in Belgium to that in Canada?
Keep it short and to the point. 0.31. What is the ratio of the CO2 emissions (% of total fuel combustion) in 1961 in Belgium to that in Canada?
Offer a terse response. 0.32. What is the ratio of the CO2 emissions (% of total fuel combustion) in 1962 in Belgium to that in Canada?
Provide a short and direct response. 0.31. What is the ratio of the CO2 emissions (% of total fuel combustion) of 1963 in Belgium to that in Canada?
Your answer should be compact. 0.28. What is the ratio of the CO2 emissions (% of total fuel combustion) in 1960 in Belgium to that in Denmark?
Give a very brief answer. 0.76. What is the ratio of the CO2 emissions (% of total fuel combustion) of 1961 in Belgium to that in Denmark?
Your response must be concise. 0.75. What is the ratio of the CO2 emissions (% of total fuel combustion) in 1962 in Belgium to that in Denmark?
Provide a succinct answer. 0.76. What is the ratio of the CO2 emissions (% of total fuel combustion) in 1963 in Belgium to that in Denmark?
Give a very brief answer. 0.7. What is the ratio of the CO2 emissions (% of total fuel combustion) in 1960 in Canada to that in Denmark?
Offer a very short reply. 2.5. What is the ratio of the CO2 emissions (% of total fuel combustion) of 1961 in Canada to that in Denmark?
Offer a very short reply. 2.34. What is the ratio of the CO2 emissions (% of total fuel combustion) in 1962 in Canada to that in Denmark?
Offer a terse response. 2.47. What is the ratio of the CO2 emissions (% of total fuel combustion) in 1963 in Canada to that in Denmark?
Make the answer very short. 2.47. What is the difference between the highest and the second highest CO2 emissions (% of total fuel combustion) in 1960?
Ensure brevity in your answer.  2.36. What is the difference between the highest and the second highest CO2 emissions (% of total fuel combustion) of 1961?
Offer a terse response. 2.88. What is the difference between the highest and the second highest CO2 emissions (% of total fuel combustion) in 1962?
Provide a short and direct response. 2.06. What is the difference between the highest and the second highest CO2 emissions (% of total fuel combustion) in 1963?
Your answer should be very brief. 1.38. What is the difference between the highest and the lowest CO2 emissions (% of total fuel combustion) in 1960?
Your answer should be very brief. 18.69. What is the difference between the highest and the lowest CO2 emissions (% of total fuel combustion) in 1961?
Keep it short and to the point. 17.98. What is the difference between the highest and the lowest CO2 emissions (% of total fuel combustion) in 1962?
Give a very brief answer. 17.99. What is the difference between the highest and the lowest CO2 emissions (% of total fuel combustion) in 1963?
Give a very brief answer. 18.51. 